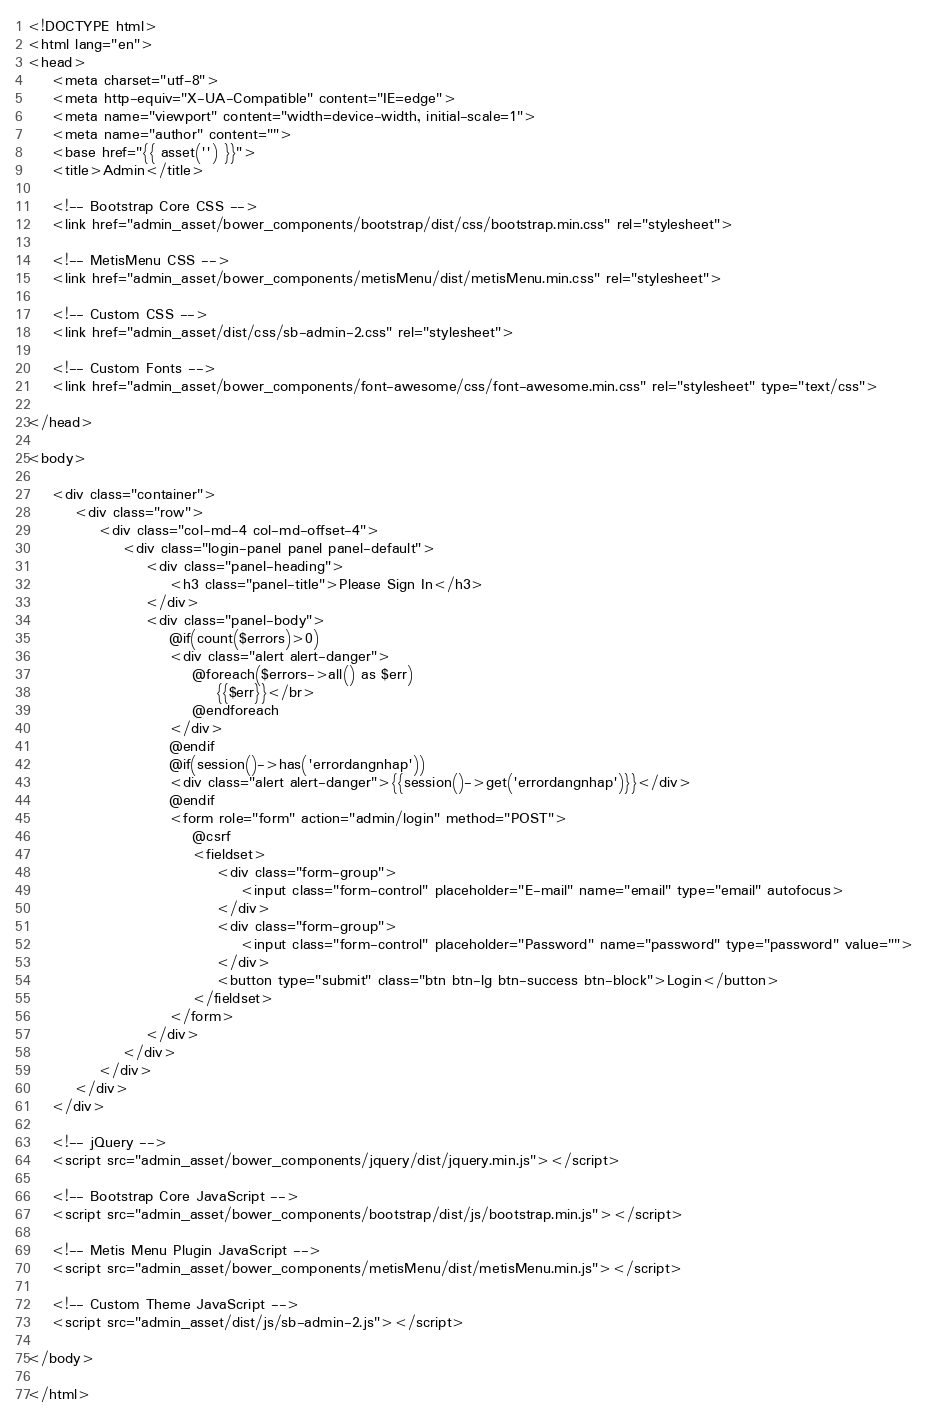Convert code to text. <code><loc_0><loc_0><loc_500><loc_500><_PHP_><!DOCTYPE html>
<html lang="en">
<head>
    <meta charset="utf-8">
    <meta http-equiv="X-UA-Compatible" content="IE=edge">
    <meta name="viewport" content="width=device-width, initial-scale=1">
    <meta name="author" content="">
    <base href="{{ asset('') }}">
    <title>Admin</title>

    <!-- Bootstrap Core CSS -->
    <link href="admin_asset/bower_components/bootstrap/dist/css/bootstrap.min.css" rel="stylesheet">

    <!-- MetisMenu CSS -->
    <link href="admin_asset/bower_components/metisMenu/dist/metisMenu.min.css" rel="stylesheet">

    <!-- Custom CSS -->
    <link href="admin_asset/dist/css/sb-admin-2.css" rel="stylesheet">

    <!-- Custom Fonts -->
    <link href="admin_asset/bower_components/font-awesome/css/font-awesome.min.css" rel="stylesheet" type="text/css">

</head>

<body>

    <div class="container">
        <div class="row">
            <div class="col-md-4 col-md-offset-4">
                <div class="login-panel panel panel-default">
                    <div class="panel-heading">
                        <h3 class="panel-title">Please Sign In</h3>
                    </div>
                    <div class="panel-body">
                        @if(count($errors)>0)
                        <div class="alert alert-danger">
                            @foreach($errors->all() as $err)
                                {{$err}}</br>
                            @endforeach
                        </div>
                        @endif
                        @if(session()->has('errordangnhap'))
                        <div class="alert alert-danger">{{session()->get('errordangnhap')}}</div>
                        @endif
                        <form role="form" action="admin/login" method="POST">
                            @csrf
                            <fieldset>
                                <div class="form-group">
                                    <input class="form-control" placeholder="E-mail" name="email" type="email" autofocus>
                                </div>
                                <div class="form-group">
                                    <input class="form-control" placeholder="Password" name="password" type="password" value="">
                                </div>
                                <button type="submit" class="btn btn-lg btn-success btn-block">Login</button>
                            </fieldset>
                        </form>
                    </div>
                </div>
            </div>
        </div>
    </div>

    <!-- jQuery -->
    <script src="admin_asset/bower_components/jquery/dist/jquery.min.js"></script>

    <!-- Bootstrap Core JavaScript -->
    <script src="admin_asset/bower_components/bootstrap/dist/js/bootstrap.min.js"></script>

    <!-- Metis Menu Plugin JavaScript -->
    <script src="admin_asset/bower_components/metisMenu/dist/metisMenu.min.js"></script>

    <!-- Custom Theme JavaScript -->
    <script src="admin_asset/dist/js/sb-admin-2.js"></script>

</body>

</html>
</code> 